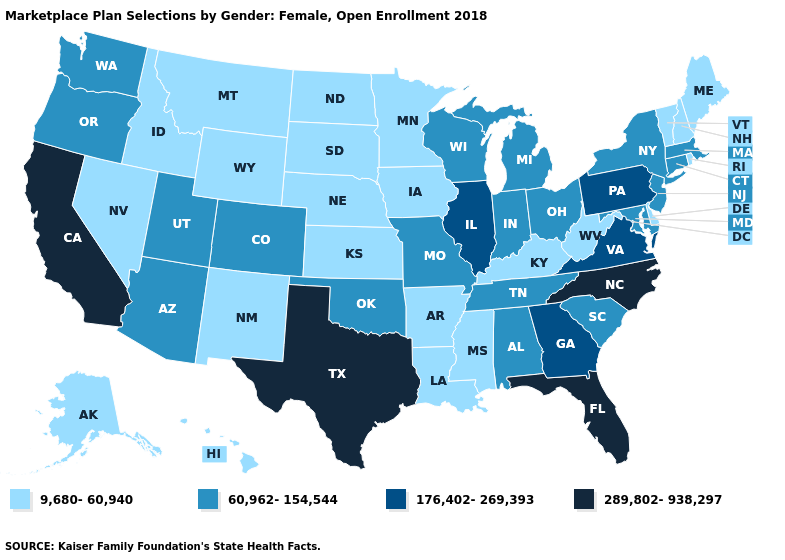Does the map have missing data?
Concise answer only. No. Name the states that have a value in the range 289,802-938,297?
Concise answer only. California, Florida, North Carolina, Texas. Which states have the highest value in the USA?
Keep it brief. California, Florida, North Carolina, Texas. What is the value of Mississippi?
Answer briefly. 9,680-60,940. Among the states that border Indiana , which have the highest value?
Give a very brief answer. Illinois. Name the states that have a value in the range 60,962-154,544?
Short answer required. Alabama, Arizona, Colorado, Connecticut, Indiana, Maryland, Massachusetts, Michigan, Missouri, New Jersey, New York, Ohio, Oklahoma, Oregon, South Carolina, Tennessee, Utah, Washington, Wisconsin. What is the value of Mississippi?
Write a very short answer. 9,680-60,940. Among the states that border Wisconsin , does Iowa have the lowest value?
Answer briefly. Yes. Name the states that have a value in the range 289,802-938,297?
Answer briefly. California, Florida, North Carolina, Texas. Does North Carolina have the same value as California?
Write a very short answer. Yes. What is the lowest value in the South?
Concise answer only. 9,680-60,940. Which states hav the highest value in the West?
Write a very short answer. California. Does Massachusetts have the lowest value in the Northeast?
Write a very short answer. No. Name the states that have a value in the range 60,962-154,544?
Concise answer only. Alabama, Arizona, Colorado, Connecticut, Indiana, Maryland, Massachusetts, Michigan, Missouri, New Jersey, New York, Ohio, Oklahoma, Oregon, South Carolina, Tennessee, Utah, Washington, Wisconsin. Name the states that have a value in the range 289,802-938,297?
Be succinct. California, Florida, North Carolina, Texas. 